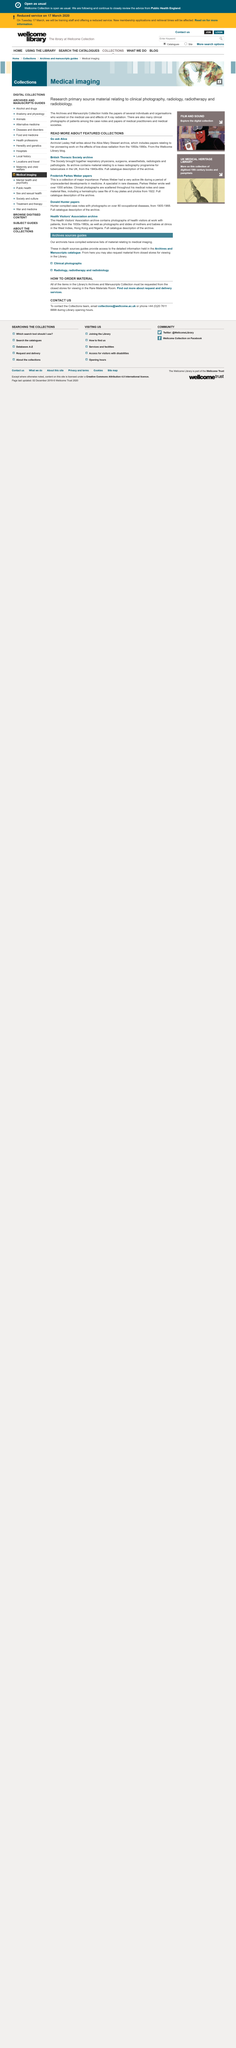Indicate a few pertinent items in this graphic. Lesley Hall is an archivist. Who can Alice be 'Go Ask'ed by? There are 4 9's. 